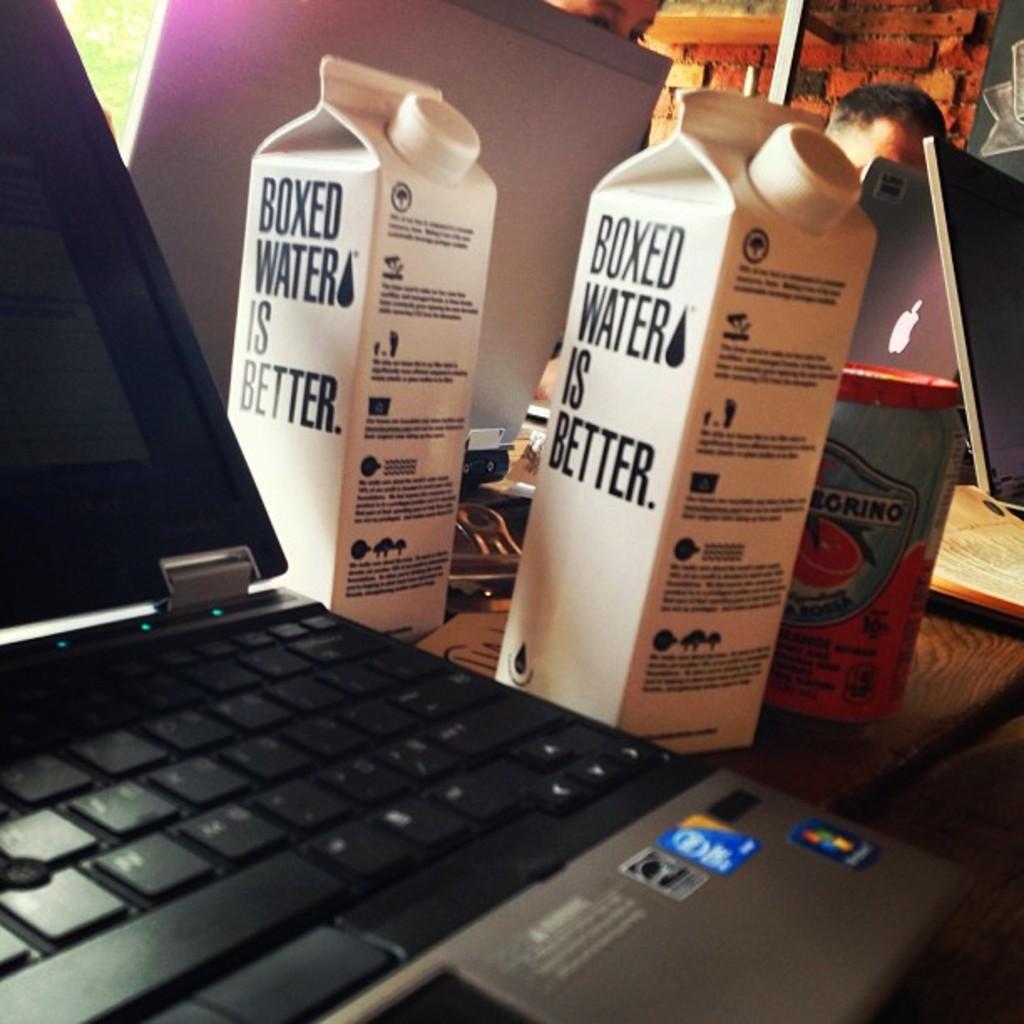What is better?
Your answer should be very brief. Boxed water. What is boxed water?
Give a very brief answer. Better. 